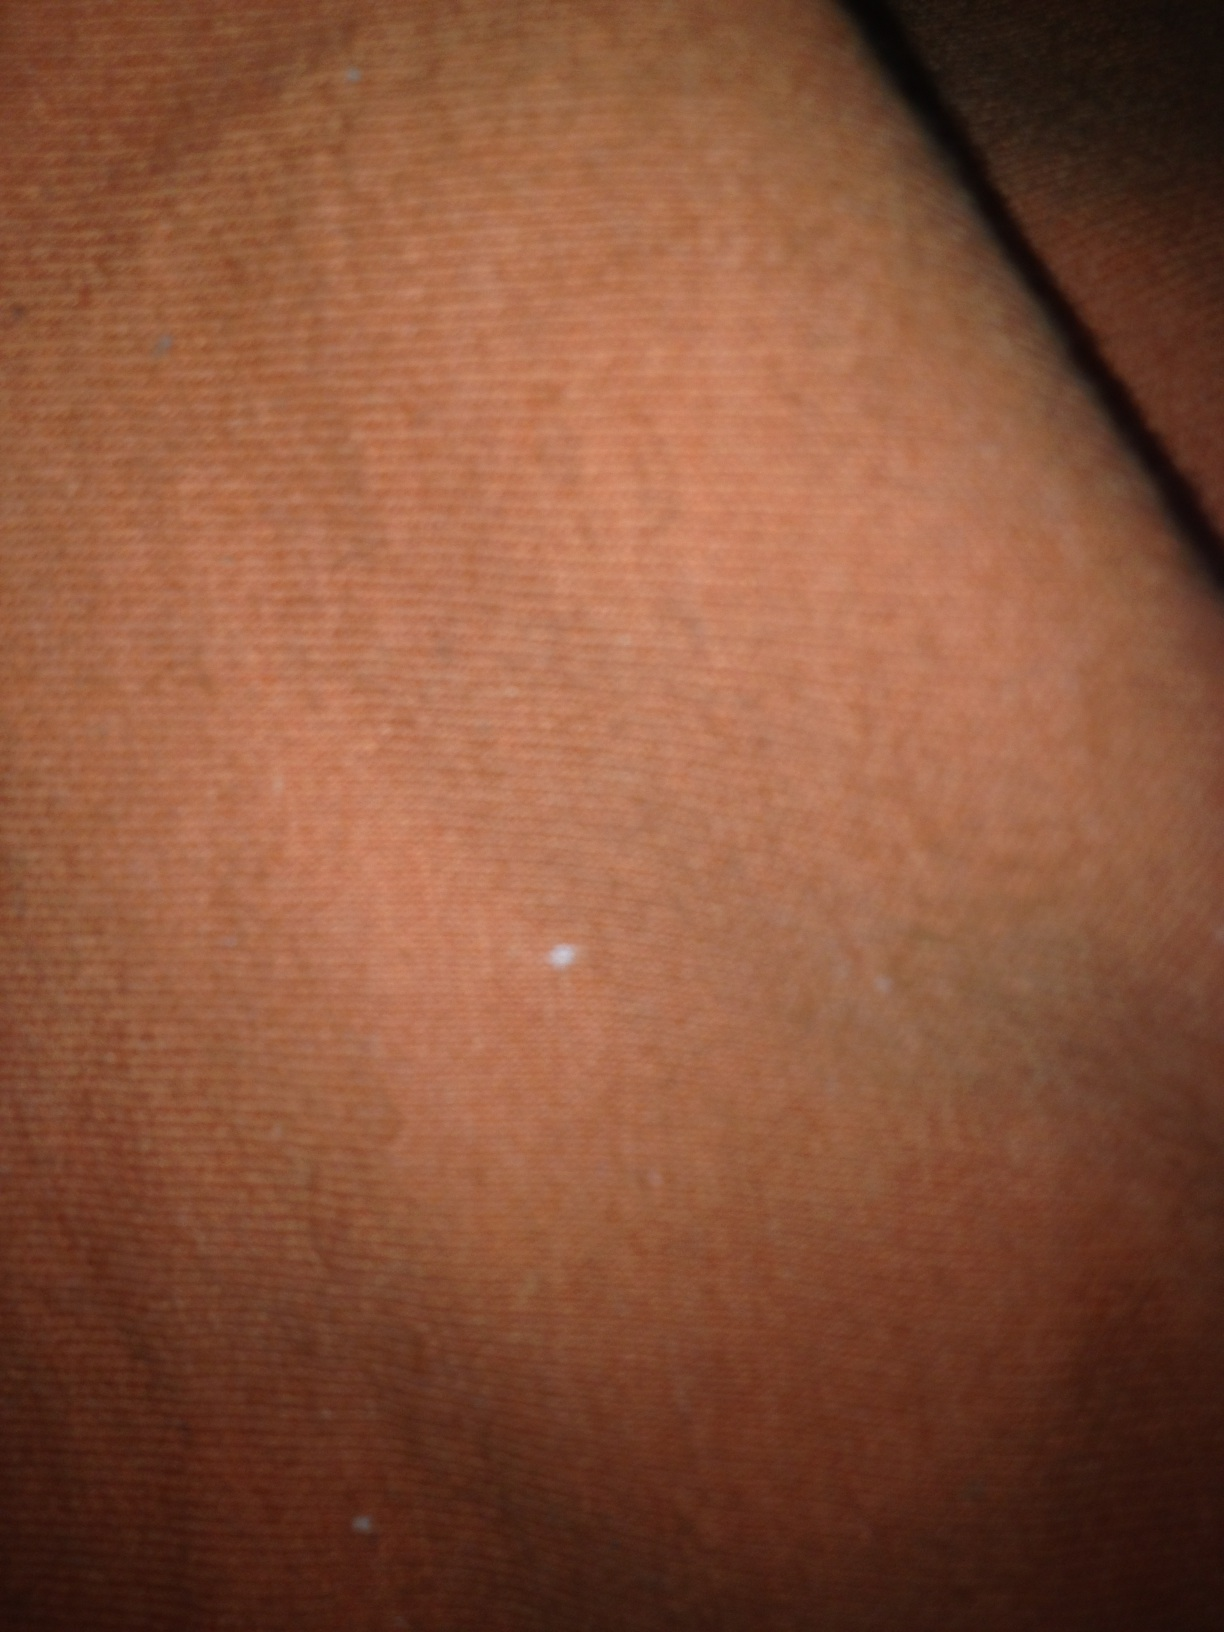Where would you find something like this? This type of fabric is commonly found in fabric stores, craft shops, and textile markets. It could also be part of home furnishings or clothing purchased from retail stores. Describe a place where this fabric could be? This fabric could be found draped over a couch in a cozy living room, adding a splash of color and warmth to the space. It could also be sewn into a bohemian-style dress, hanging in a rustic boutique, or even used as curtains in a sunlit room, filtering the light into a warm, inviting glow. What kind of people might use this fabric? This fabric would likely be appreciated by people who enjoy creating handmade decorations or clothing. It would be popular among tailors, fashion designers, craft enthusiasts, and interior decorators. It could also appeal to individuals who appreciate vibrant colors and natural textures. 